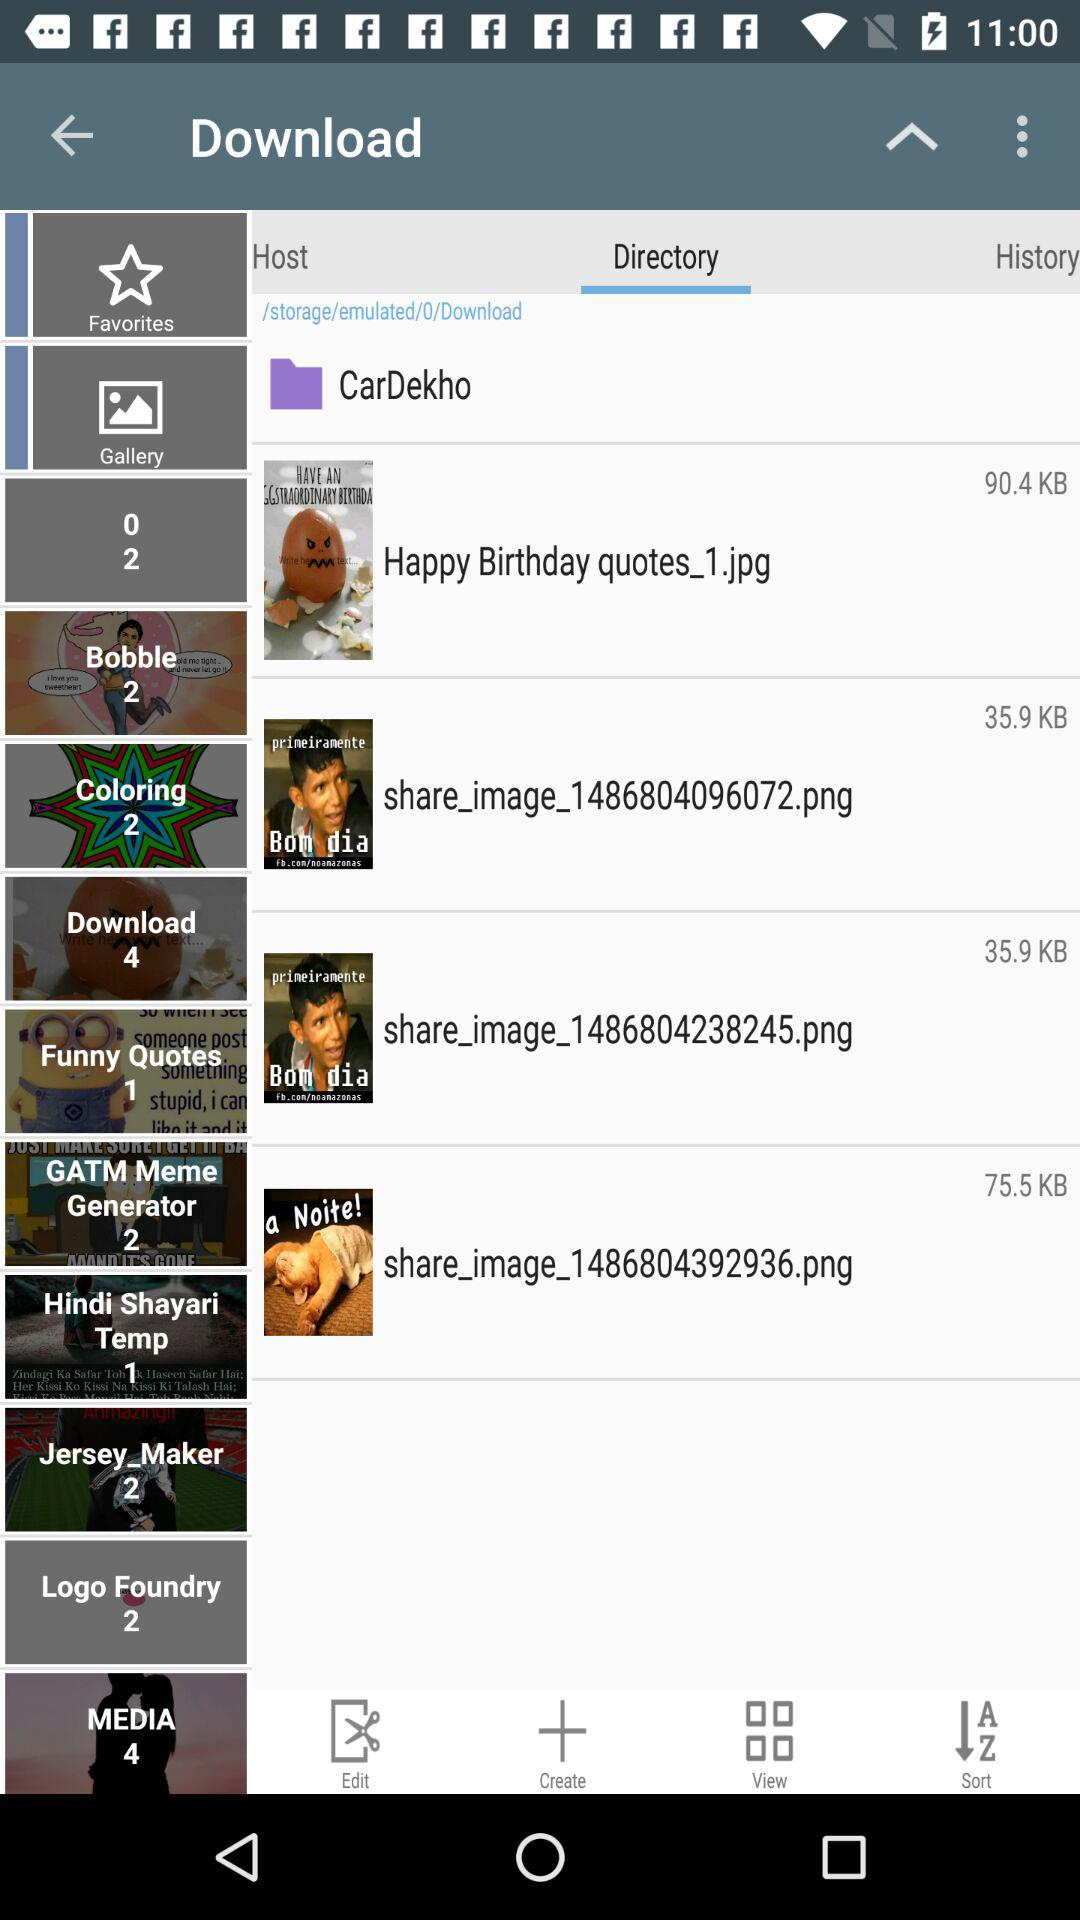What tab is selected? The selected tab is "Directory". 